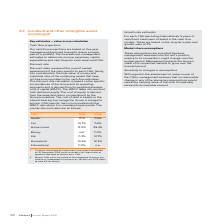According to Iselect's financial document, What is the recoverable amount of the Home loans CGU as at 31 December 2018? Based on the financial document, the answer is $5.6m. Also, What is the pre-tax discount rate applied to cash flow projections in 2019? Based on the financial document, the answer is 13%. Also, What are the cash flow projections based on? five-year management-approved forecasts. The document states: "Our cash flow projections are based on five-year management-approved forecasts unless a longer period is justified. The forecasts use management estim..." Additionally, In which year is the health CGU higher? According to the financial document, FY18. The relevant text states: "CGU FY19 FY18..." Additionally, In which year is the car CGU higher? According to the financial document, FY19. The relevant text states: "CGU FY19 FY18..." Additionally, In which year is the household CGU higher? According to the financial document, FY18. The relevant text states: "CGU FY19 FY18..." 